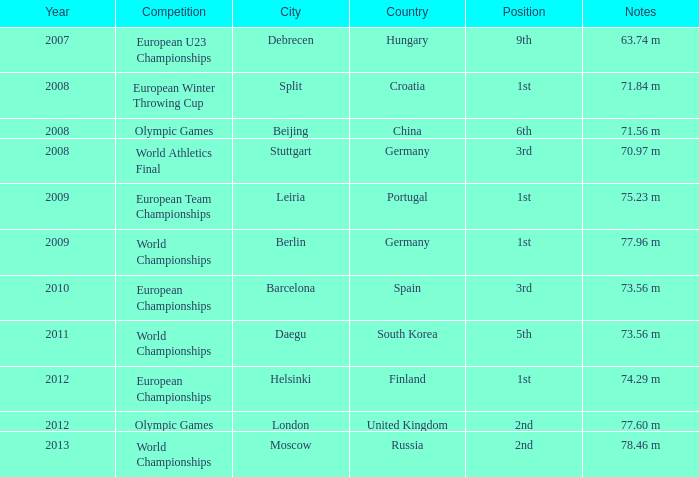Which year corresponds to the 9th rank? 2007.0. 